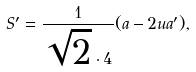Convert formula to latex. <formula><loc_0><loc_0><loc_500><loc_500>S ^ { \prime } = \frac { 1 } { \sqrt { 2 } \cdot 4 } ( a - 2 u a ^ { \prime } ) ,</formula> 